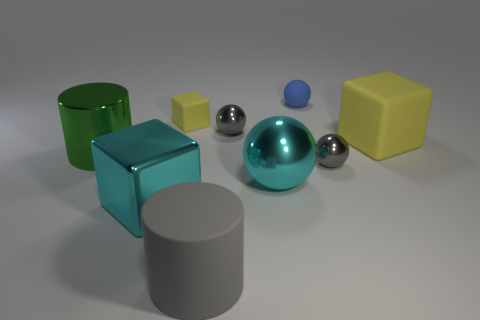Is the large yellow object made of the same material as the cylinder left of the large rubber cylinder?
Your answer should be very brief. No. How many things are tiny green metallic things or big gray objects?
Provide a succinct answer. 1. What material is the thing that is the same color as the big matte block?
Make the answer very short. Rubber. Are there any other things that have the same shape as the large gray object?
Your answer should be very brief. Yes. How many yellow cubes are right of the shiny cube?
Your response must be concise. 2. What material is the large block that is left of the cyan metal thing behind the shiny cube?
Offer a very short reply. Metal. There is a green cylinder that is the same size as the cyan metallic ball; what is its material?
Give a very brief answer. Metal. Are there any green metal balls that have the same size as the blue object?
Provide a short and direct response. No. What color is the large block right of the small blue rubber thing?
Provide a short and direct response. Yellow. There is a tiny gray ball that is on the right side of the big shiny ball; is there a gray cylinder that is behind it?
Your answer should be very brief. No. 